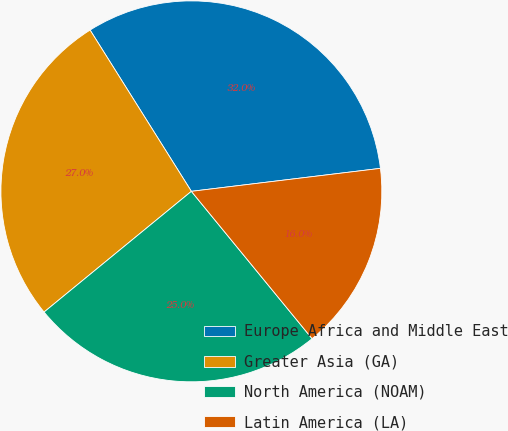Convert chart to OTSL. <chart><loc_0><loc_0><loc_500><loc_500><pie_chart><fcel>Europe Africa and Middle East<fcel>Greater Asia (GA)<fcel>North America (NOAM)<fcel>Latin America (LA)<nl><fcel>32.0%<fcel>27.0%<fcel>25.0%<fcel>16.0%<nl></chart> 